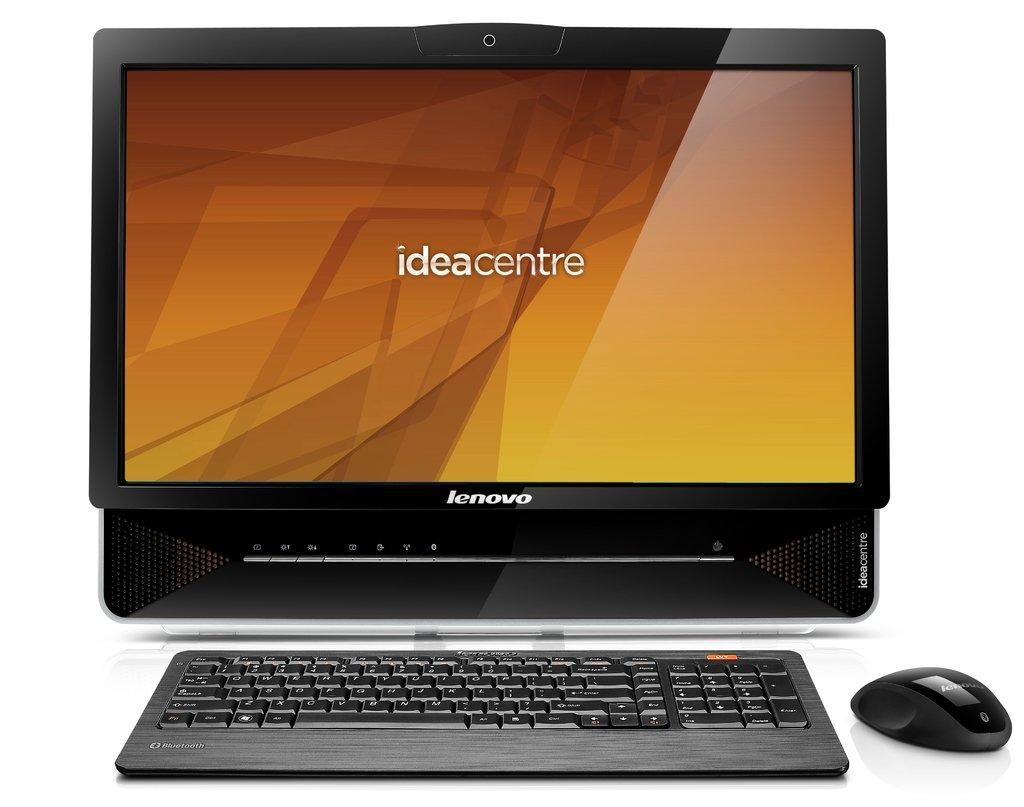<image>
Describe the image concisely. Lenovo computer screen and keyboard that has the text Ideacentre on the center of the screen. 